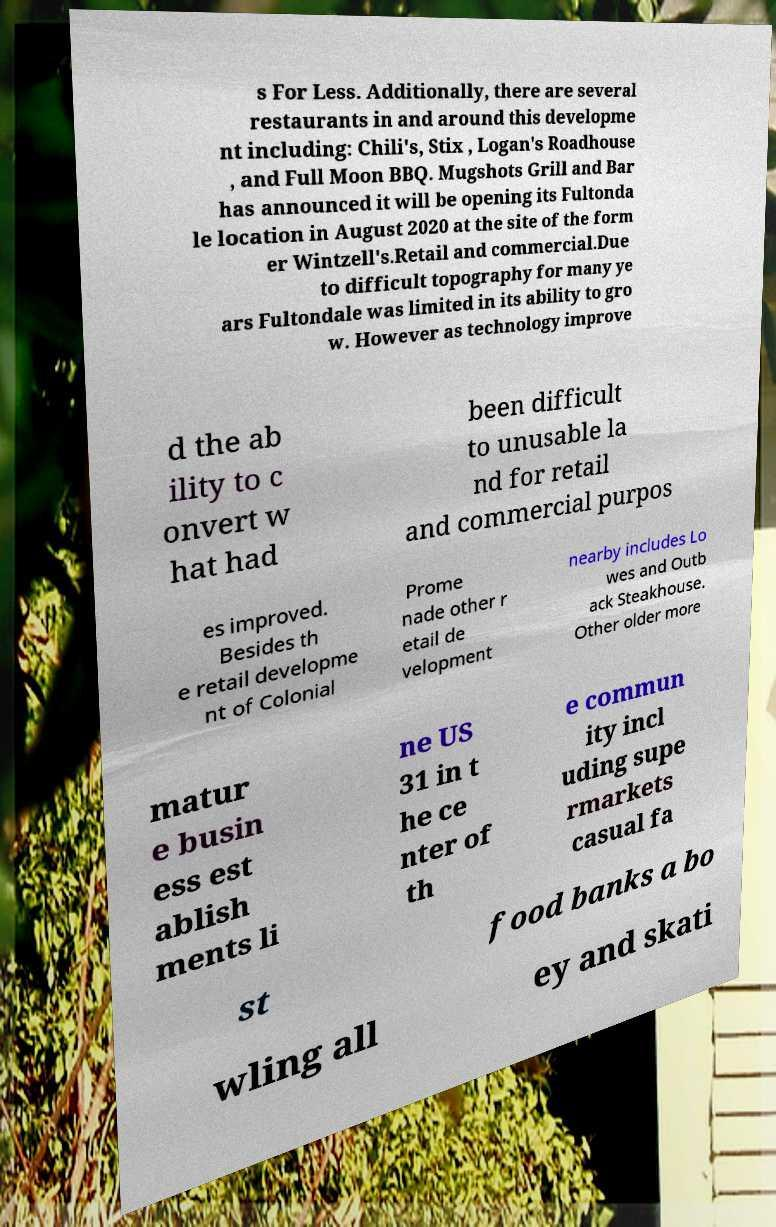There's text embedded in this image that I need extracted. Can you transcribe it verbatim? s For Less. Additionally, there are several restaurants in and around this developme nt including: Chili's, Stix , Logan's Roadhouse , and Full Moon BBQ. Mugshots Grill and Bar has announced it will be opening its Fultonda le location in August 2020 at the site of the form er Wintzell's.Retail and commercial.Due to difficult topography for many ye ars Fultondale was limited in its ability to gro w. However as technology improve d the ab ility to c onvert w hat had been difficult to unusable la nd for retail and commercial purpos es improved. Besides th e retail developme nt of Colonial Prome nade other r etail de velopment nearby includes Lo wes and Outb ack Steakhouse. Other older more matur e busin ess est ablish ments li ne US 31 in t he ce nter of th e commun ity incl uding supe rmarkets casual fa st food banks a bo wling all ey and skati 